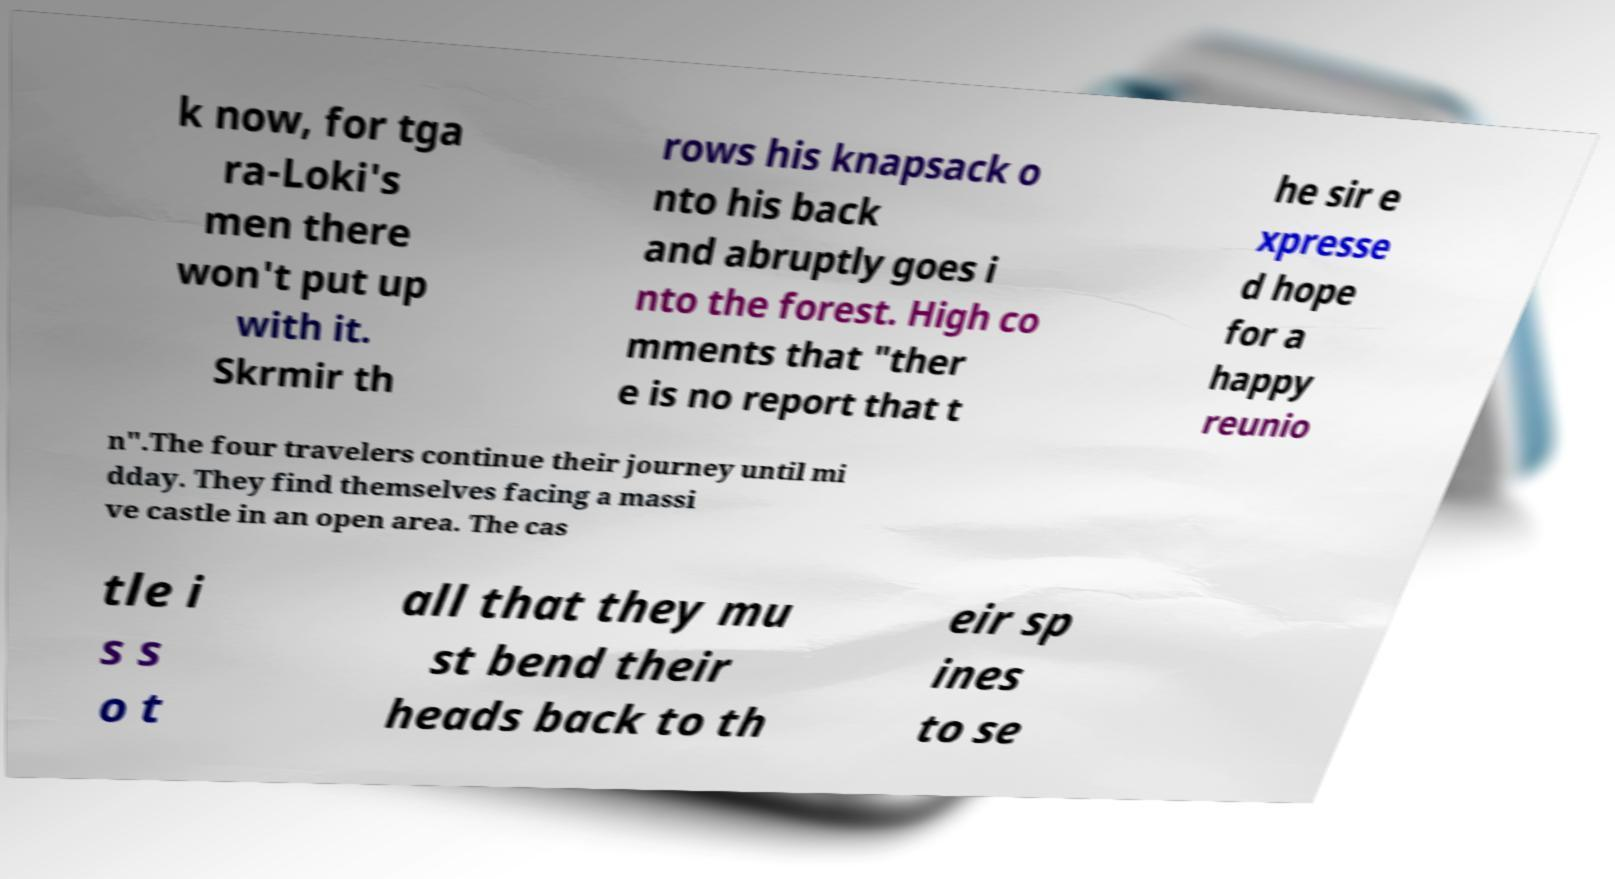There's text embedded in this image that I need extracted. Can you transcribe it verbatim? k now, for tga ra-Loki's men there won't put up with it. Skrmir th rows his knapsack o nto his back and abruptly goes i nto the forest. High co mments that "ther e is no report that t he sir e xpresse d hope for a happy reunio n".The four travelers continue their journey until mi dday. They find themselves facing a massi ve castle in an open area. The cas tle i s s o t all that they mu st bend their heads back to th eir sp ines to se 